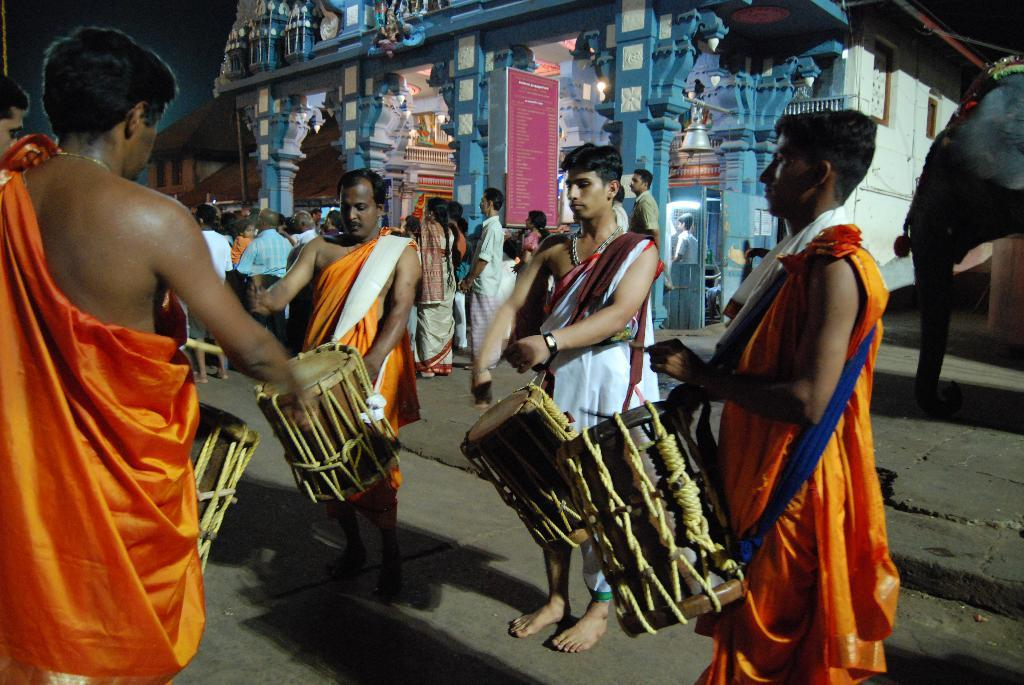How many people are in the image? There is a group of people in the image. What are the people doing in the image? The people are standing and holding drums. What can be seen in the background of the image? There is a road, a temple, a banner, the sky, and a house in the background of the image. What type of feather can be seen guiding the group of people in the image? There is no feather present in the image, and therefore no such guiding can be observed. 